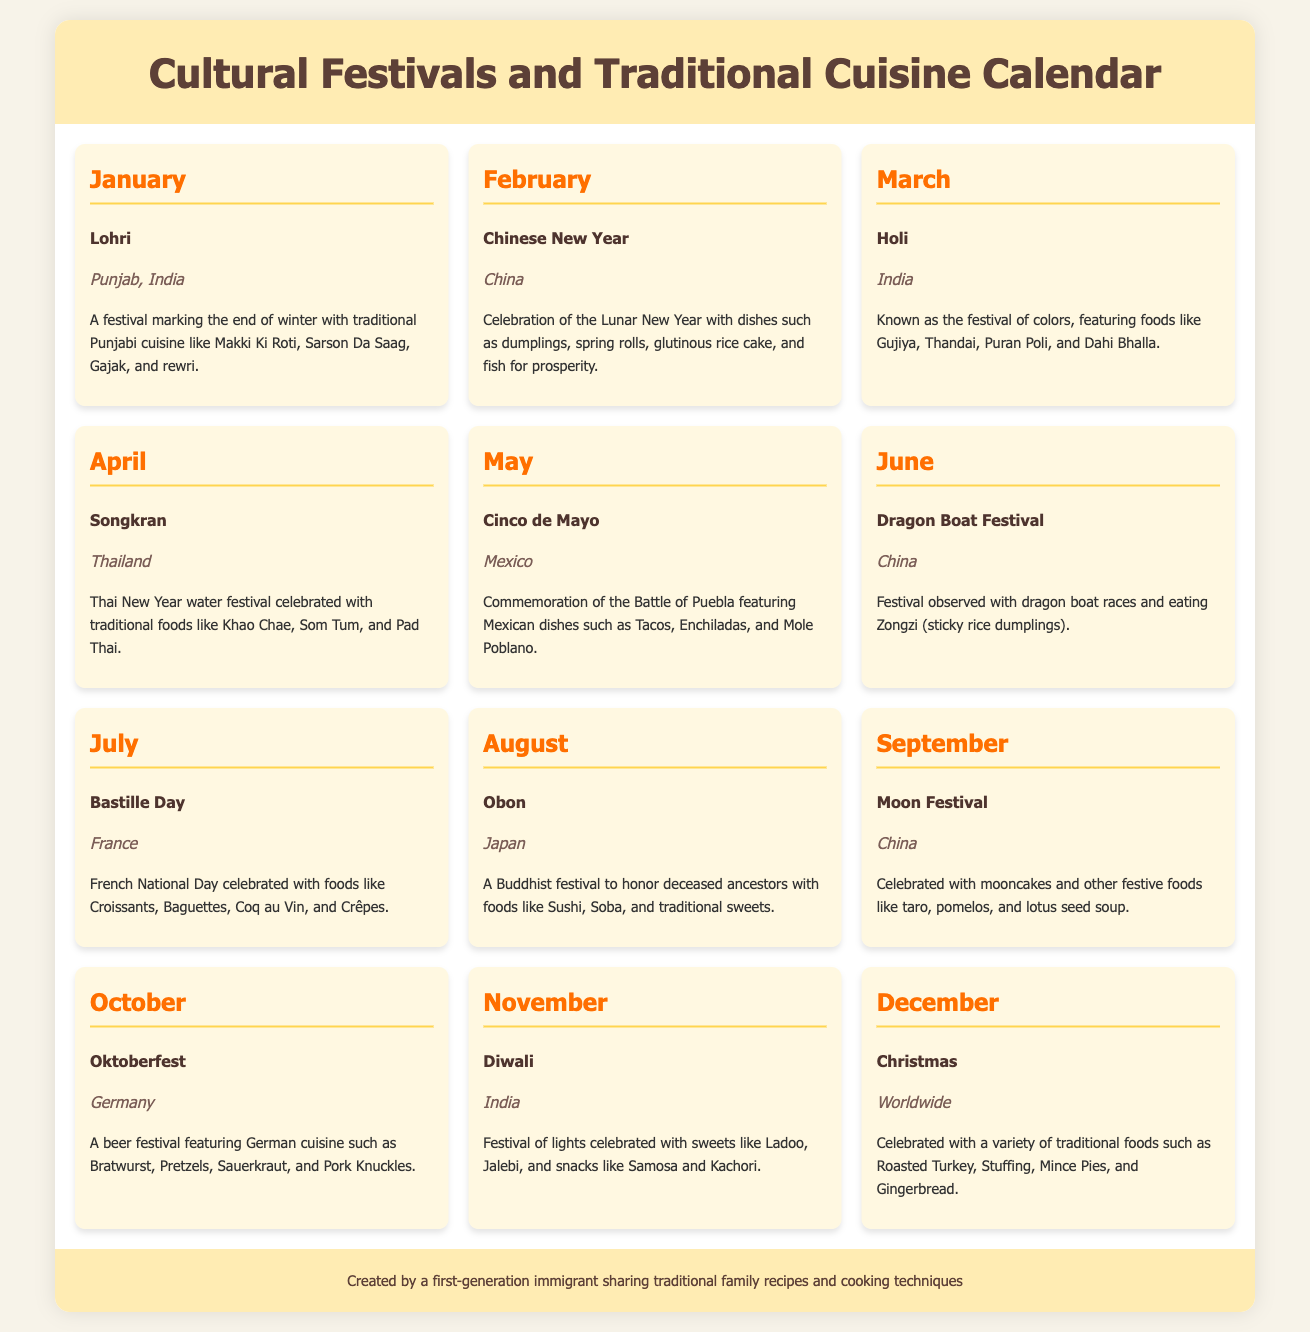What is the event celebrated in January? The document states that Lohri is the event celebrated in January.
Answer: Lohri What traditional dish is associated with the Chinese New Year? According to the document, dumplings are a traditional dish associated with the Chinese New Year.
Answer: Dumplings Which month celebrates Bastille Day? The document indicates that Bastille Day is celebrated in July.
Answer: July What region is known for the festival of Diwali? The document specifies that India is the region known for celebrating Diwali.
Answer: India How many events are listed for the month of December? The document shows that there is one event, Christmas, listed for December.
Answer: 1 Which festival features the dish Khao Chae? The document mentions that the festival Songkran features the dish Khao Chae.
Answer: Songkran What type of cuisine is highlighted during Oktoberfest? According to the document, German cuisine is highlighted during Oktoberfest.
Answer: German What is the primary focus of the calendar document? The document focuses on cultural festivals and events highlighting traditional cuisine.
Answer: Cultural festivals and events highlighting traditional cuisine Which festival is associated with mooncakes? The document lists the Moon Festival as being associated with mooncakes.
Answer: Moon Festival 